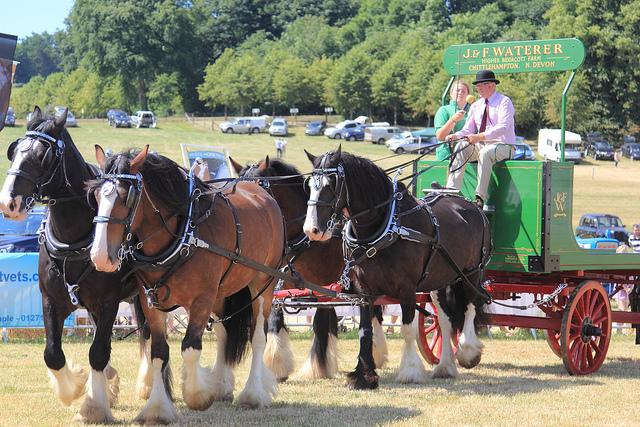What is the guy wearing a black hat doing?

Choices:
A) singing
B) talking
C) resting
D) listening talking 